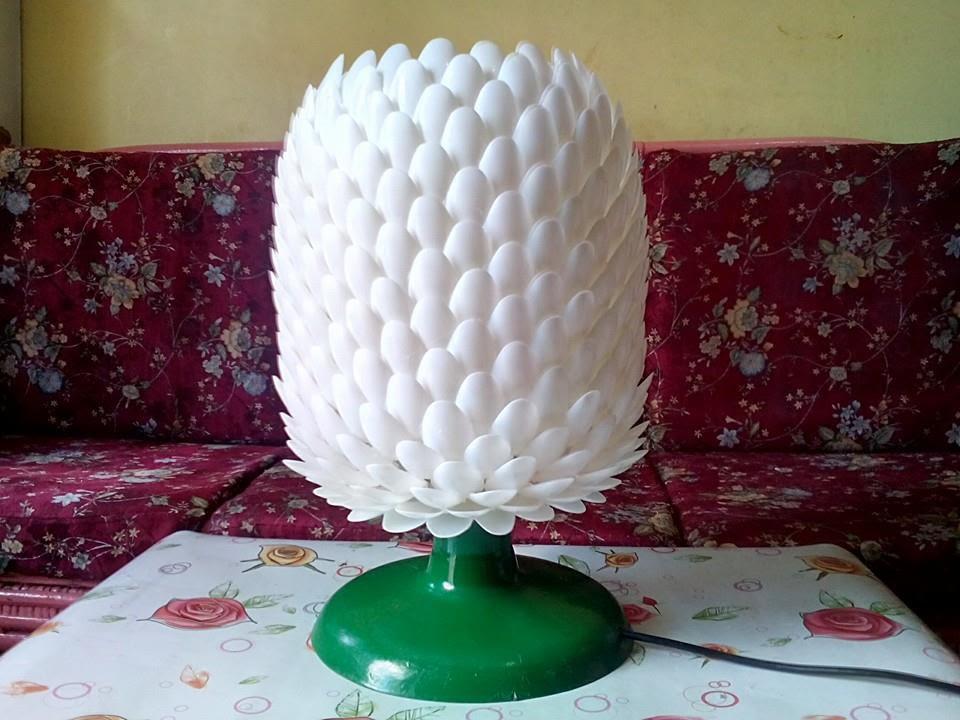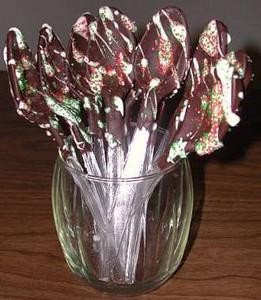The first image is the image on the left, the second image is the image on the right. Considering the images on both sides, is "In one image the object rests on a tablecloth and in the other image it rests on bare wood." valid? Answer yes or no. Yes. The first image is the image on the left, the second image is the image on the right. Considering the images on both sides, is "An image shows a white vase resembling an artichoke, filled with red lily-type flowers and sitting on a table." valid? Answer yes or no. No. 